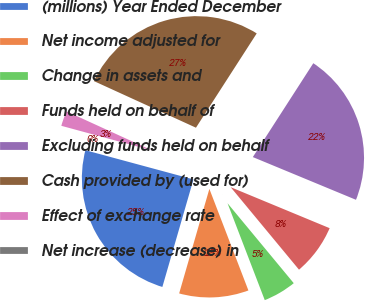Convert chart. <chart><loc_0><loc_0><loc_500><loc_500><pie_chart><fcel>(millions) Year Ended December<fcel>Net income adjusted for<fcel>Change in assets and<fcel>Funds held on behalf of<fcel>Excluding funds held on behalf<fcel>Cash provided by (used for)<fcel>Effect of exchange rate<fcel>Net increase (decrease) in<nl><fcel>24.72%<fcel>10.32%<fcel>5.17%<fcel>7.74%<fcel>22.14%<fcel>27.29%<fcel>2.6%<fcel>0.02%<nl></chart> 